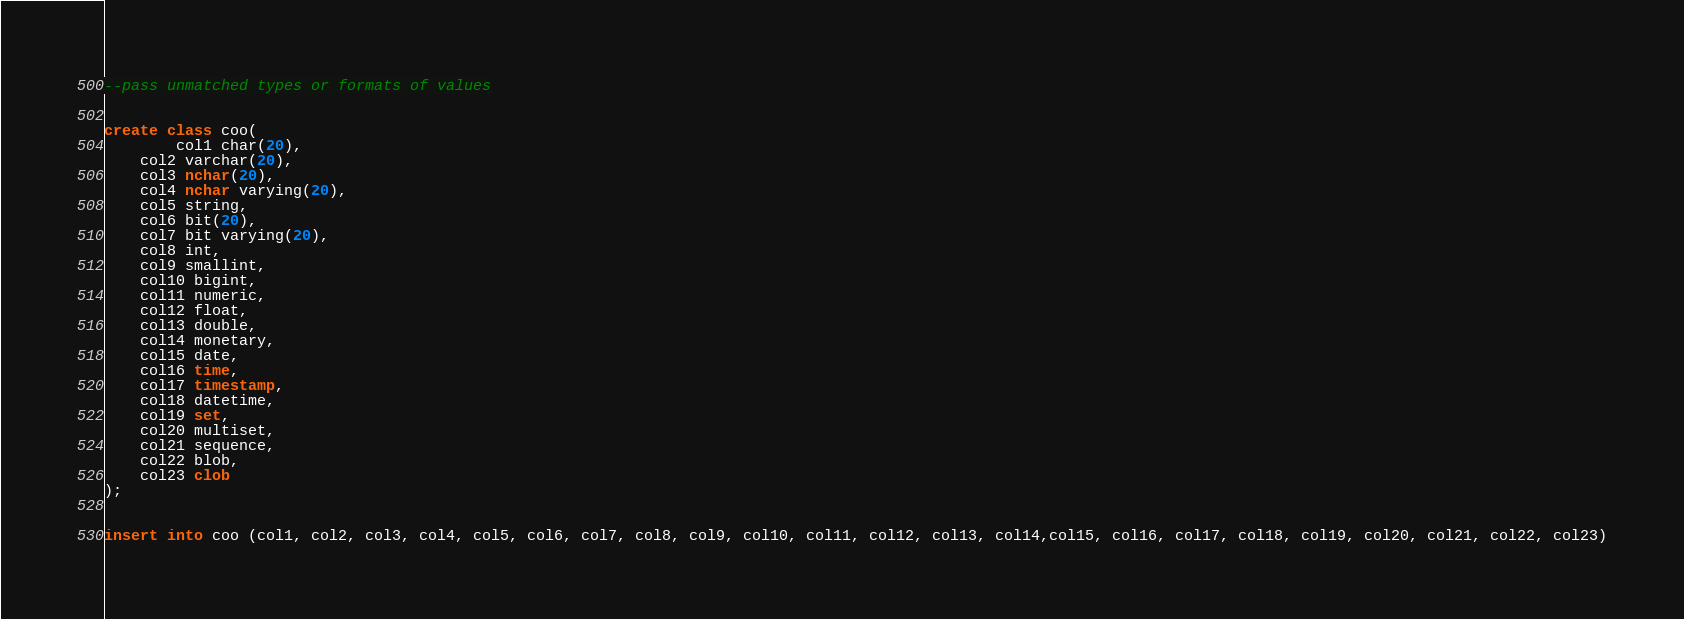Convert code to text. <code><loc_0><loc_0><loc_500><loc_500><_SQL_>--pass unmatched types or formats of values


create class coo(
        col1 char(20),
	col2 varchar(20),
	col3 nchar(20),
	col4 nchar varying(20),
	col5 string,
	col6 bit(20),
	col7 bit varying(20),
	col8 int,
	col9 smallint,
	col10 bigint,
	col11 numeric,
	col12 float,
	col13 double,
	col14 monetary,
	col15 date,
	col16 time,
	col17 timestamp,
	col18 datetime,
	col19 set,
	col20 multiset,
	col21 sequence,
	col22 blob,
	col23 clob
);


insert into coo (col1, col2, col3, col4, col5, col6, col7, col8, col9, col10, col11, col12, col13, col14,col15, col16, col17, col18, col19, col20, col21, col22, col23)</code> 